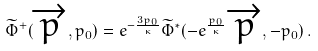<formula> <loc_0><loc_0><loc_500><loc_500>\widetilde { \Phi } ^ { + } ( \overrightarrow { p } , p _ { 0 } ) = e ^ { - \frac { 3 p _ { 0 } } { \kappa } } \widetilde { \Phi } ^ { * } ( - e ^ { \frac { p _ { 0 } } { \kappa } } \, \overrightarrow { p } , - p _ { 0 } ) \, .</formula> 